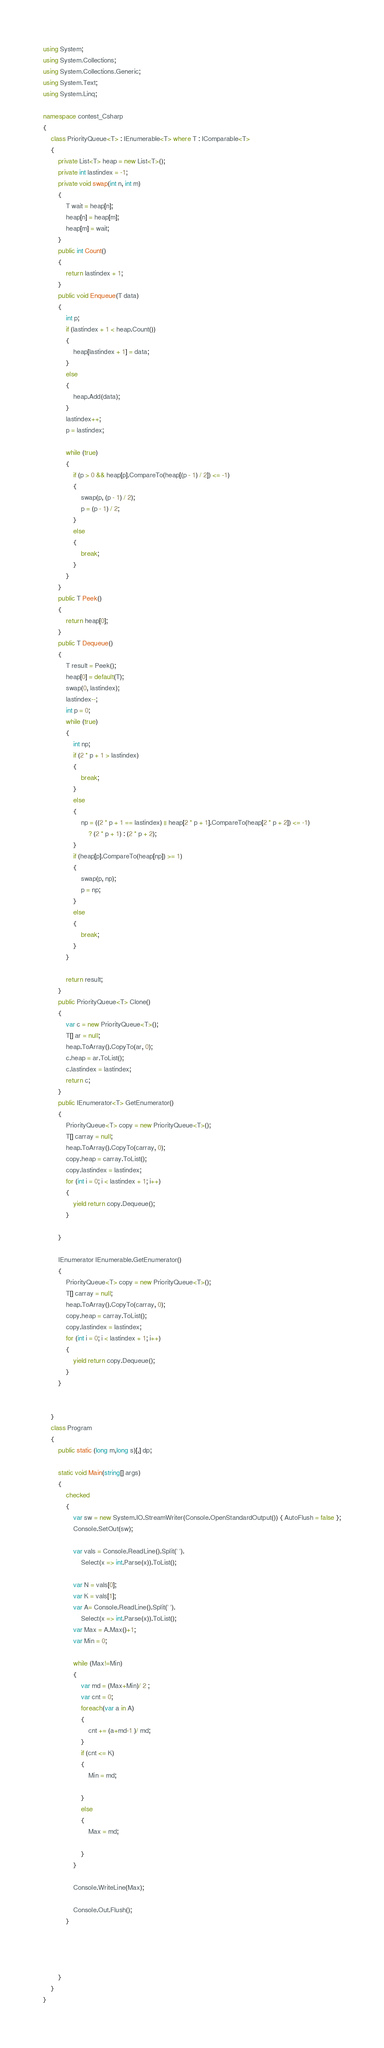<code> <loc_0><loc_0><loc_500><loc_500><_C#_>using System;
using System.Collections;
using System.Collections.Generic;
using System.Text;
using System.Linq;

namespace contest_Csharp
{
    class PriorityQueue<T> : IEnumerable<T> where T : IComparable<T>
    {
        private List<T> heap = new List<T>();
        private int lastindex = -1;
        private void swap(int n, int m)
        {
            T wait = heap[n];
            heap[n] = heap[m];
            heap[m] = wait;
        }
        public int Count()
        {
            return lastindex + 1;
        }
        public void Enqueue(T data)
        {
            int p;
            if (lastindex + 1 < heap.Count())
            {
                heap[lastindex + 1] = data;
            }
            else
            {
                heap.Add(data);
            }
            lastindex++;
            p = lastindex;

            while (true)
            {
                if (p > 0 && heap[p].CompareTo(heap[(p - 1) / 2]) <= -1)
                {
                    swap(p, (p - 1) / 2);
                    p = (p - 1) / 2;
                }
                else
                {
                    break;
                }
            }
        }
        public T Peek()
        {
            return heap[0];
        }
        public T Dequeue()
        {
            T result = Peek();
            heap[0] = default(T);
            swap(0, lastindex);
            lastindex--;
            int p = 0;
            while (true)
            {
                int np;
                if (2 * p + 1 > lastindex)
                {
                    break;
                }
                else
                {
                    np = ((2 * p + 1 == lastindex) || heap[2 * p + 1].CompareTo(heap[2 * p + 2]) <= -1)
                        ? (2 * p + 1) : (2 * p + 2);
                }
                if (heap[p].CompareTo(heap[np]) >= 1)
                {
                    swap(p, np);
                    p = np;
                }
                else
                {
                    break;
                }
            }

            return result;
        }
        public PriorityQueue<T> Clone()
        {
            var c = new PriorityQueue<T>();
            T[] ar = null;
            heap.ToArray().CopyTo(ar, 0);
            c.heap = ar.ToList();
            c.lastindex = lastindex;
            return c;
        }
        public IEnumerator<T> GetEnumerator()
        {
            PriorityQueue<T> copy = new PriorityQueue<T>();
            T[] carray = null;
            heap.ToArray().CopyTo(carray, 0);
            copy.heap = carray.ToList();
            copy.lastindex = lastindex;
            for (int i = 0; i < lastindex + 1; i++)
            {
                yield return copy.Dequeue();
            }

        }

        IEnumerator IEnumerable.GetEnumerator()
        {
            PriorityQueue<T> copy = new PriorityQueue<T>();
            T[] carray = null;
            heap.ToArray().CopyTo(carray, 0);
            copy.heap = carray.ToList();
            copy.lastindex = lastindex;
            for (int i = 0; i < lastindex + 1; i++)
            {
                yield return copy.Dequeue();
            }
        }


    }
    class Program
    {
        public static (long m,long s)[,] dp;

        static void Main(string[] args)
        {
            checked
            {
                var sw = new System.IO.StreamWriter(Console.OpenStandardOutput()) { AutoFlush = false };
                Console.SetOut(sw);

                var vals = Console.ReadLine().Split(' ').
                    Select(x => int.Parse(x)).ToList();

                var N = vals[0];
                var K = vals[1];
                var A= Console.ReadLine().Split(' ').
                    Select(x => int.Parse(x)).ToList();
                var Max = A.Max()+1;
                var Min = 0;

                while (Max!=Min)
                {
                    var md = (Max+Min)/ 2 ;
                    var cnt = 0;
                    foreach(var a in A)
                    {
                        cnt += (a+md-1 )/ md;
                    }
                    if (cnt <= K)
                    {
                        Min = md;

                    }
                    else
                    {
                        Max = md;

                    }
                }

                Console.WriteLine(Max);

                Console.Out.Flush();
            }




        }
    }
}


</code> 